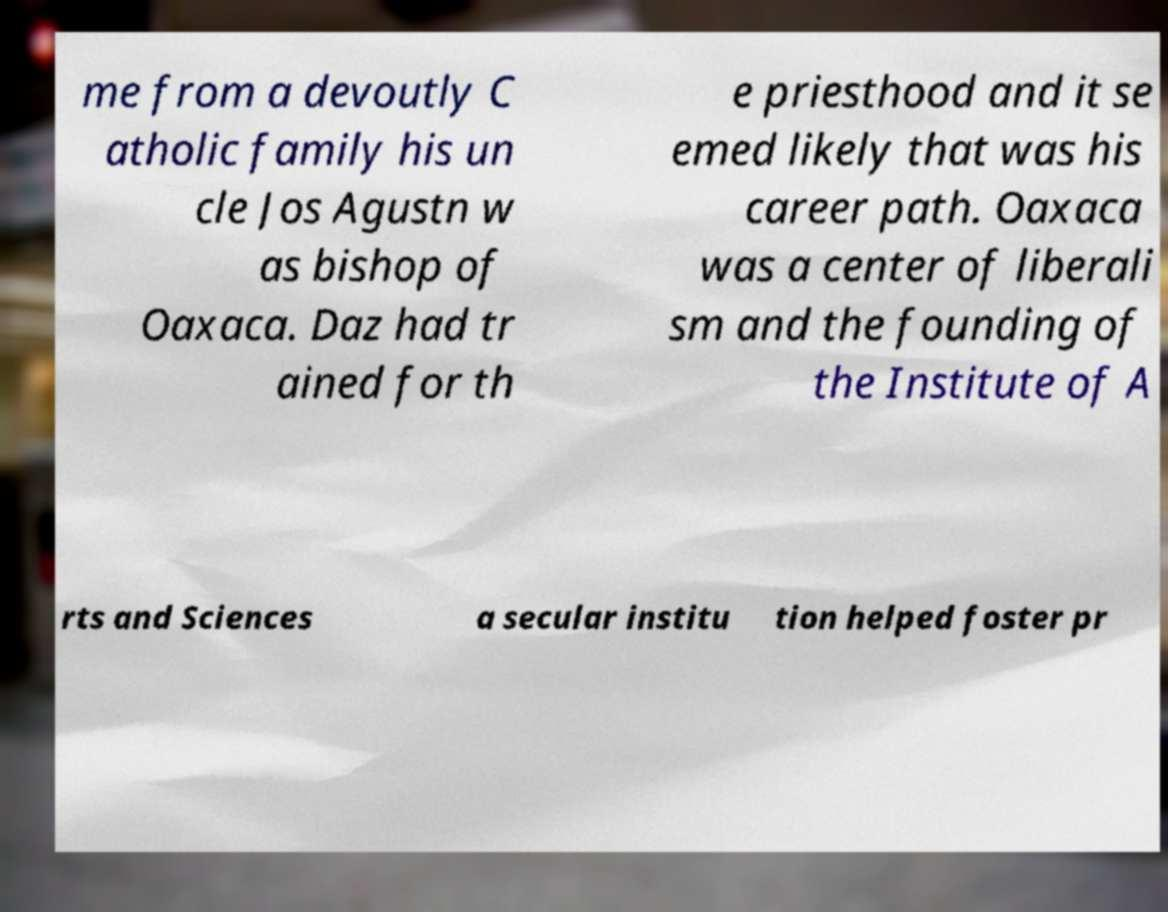Could you assist in decoding the text presented in this image and type it out clearly? me from a devoutly C atholic family his un cle Jos Agustn w as bishop of Oaxaca. Daz had tr ained for th e priesthood and it se emed likely that was his career path. Oaxaca was a center of liberali sm and the founding of the Institute of A rts and Sciences a secular institu tion helped foster pr 